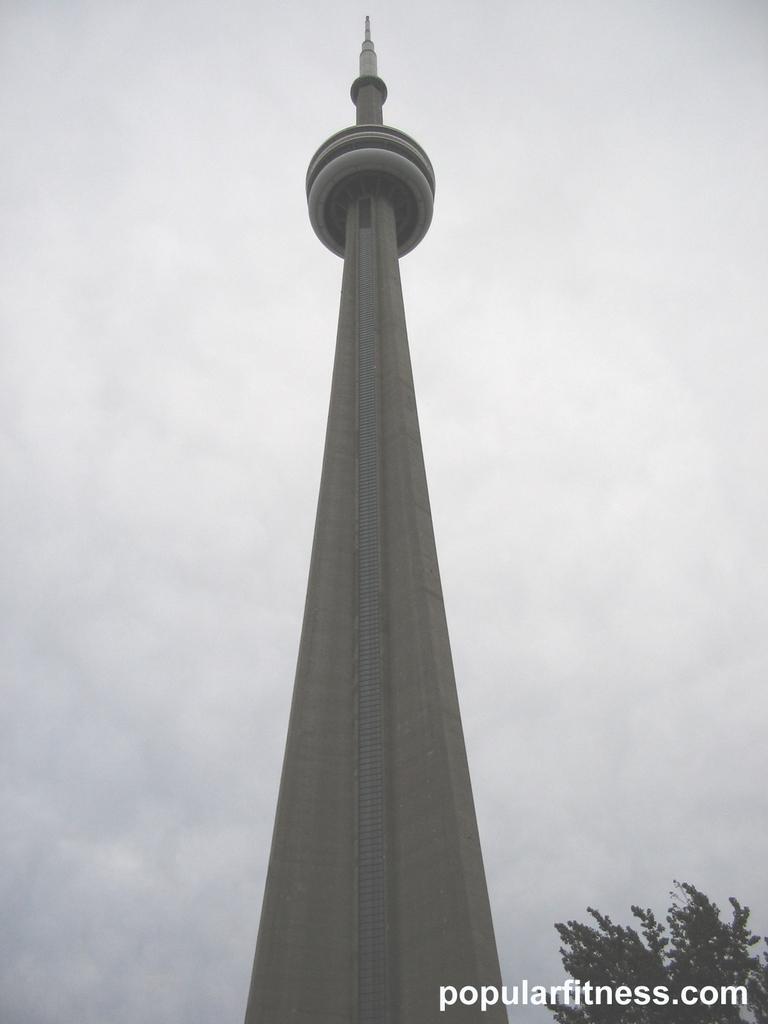Can you describe this image briefly? In this image we can see the tower. And we can see the trees and clouds in the sky. 